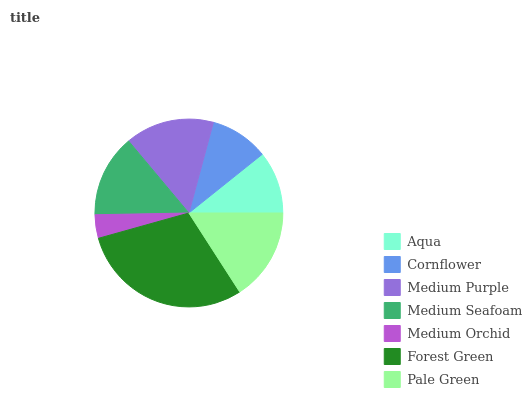Is Medium Orchid the minimum?
Answer yes or no. Yes. Is Forest Green the maximum?
Answer yes or no. Yes. Is Cornflower the minimum?
Answer yes or no. No. Is Cornflower the maximum?
Answer yes or no. No. Is Aqua greater than Cornflower?
Answer yes or no. Yes. Is Cornflower less than Aqua?
Answer yes or no. Yes. Is Cornflower greater than Aqua?
Answer yes or no. No. Is Aqua less than Cornflower?
Answer yes or no. No. Is Medium Seafoam the high median?
Answer yes or no. Yes. Is Medium Seafoam the low median?
Answer yes or no. Yes. Is Forest Green the high median?
Answer yes or no. No. Is Aqua the low median?
Answer yes or no. No. 